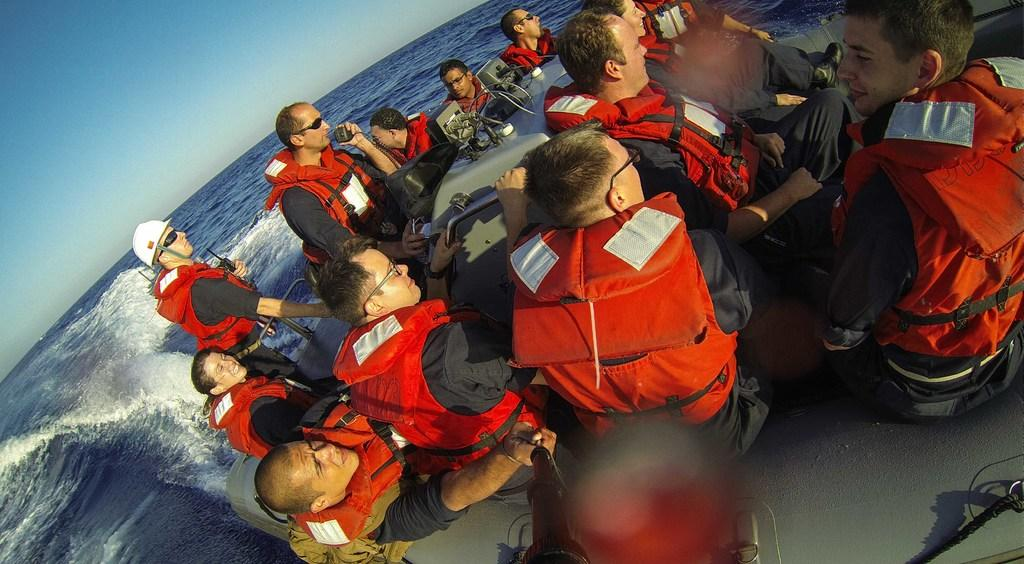How many people are in the image? There are persons in the image. What are the persons wearing in the image? The persons are wearing life jackets. What are the persons sitting on in the image? The persons are sitting on a boat. What is the boat doing in the image? The boat is floating on water. What can be seen in the top left of the image? There is a sky visible in the top left of the image. How many visitors are in the image? There is no mention of visitors in the image. --- Facts: 1. There is a person in the image. 2. The person is holding a book. 3. The book is titled "The Art of War" by Sun Tzu. 4. The person is sitting on a chair. 5. The chair is made of wood. Absurd Topics: elephant, piano, dance Conversation: What is the main subject in the image? There is a person in the image. What is the person holding in the image? The person is holding a book. What is the title of the book the person is holding? The book is titled "The Art of War" by Sun Tzu. What is the person's posture in the image? The person is sitting on a chair. What is the chair made of? The chair is made of wood. Reasoning: Let's think step by step in order to ${produce the conversation}. We start by identifying the main subject of the image, which is the person. Next, we describe what the person is holding, which is a book. Then, we identify the title of the book, which is "The Art of War" by Sun Tzu. After that, we observe the person's posture, which is sitting on a chair. Finally, we describe the material of the chair, which is made of wood. Absurd Question/Answer: Can you hear the elephant playing the piano in the image? There is no mention of an elephant, a piano, or any dance in the image. 